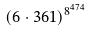Convert formula to latex. <formula><loc_0><loc_0><loc_500><loc_500>( 6 \cdot 3 6 1 ) ^ { 8 ^ { 4 7 4 } }</formula> 